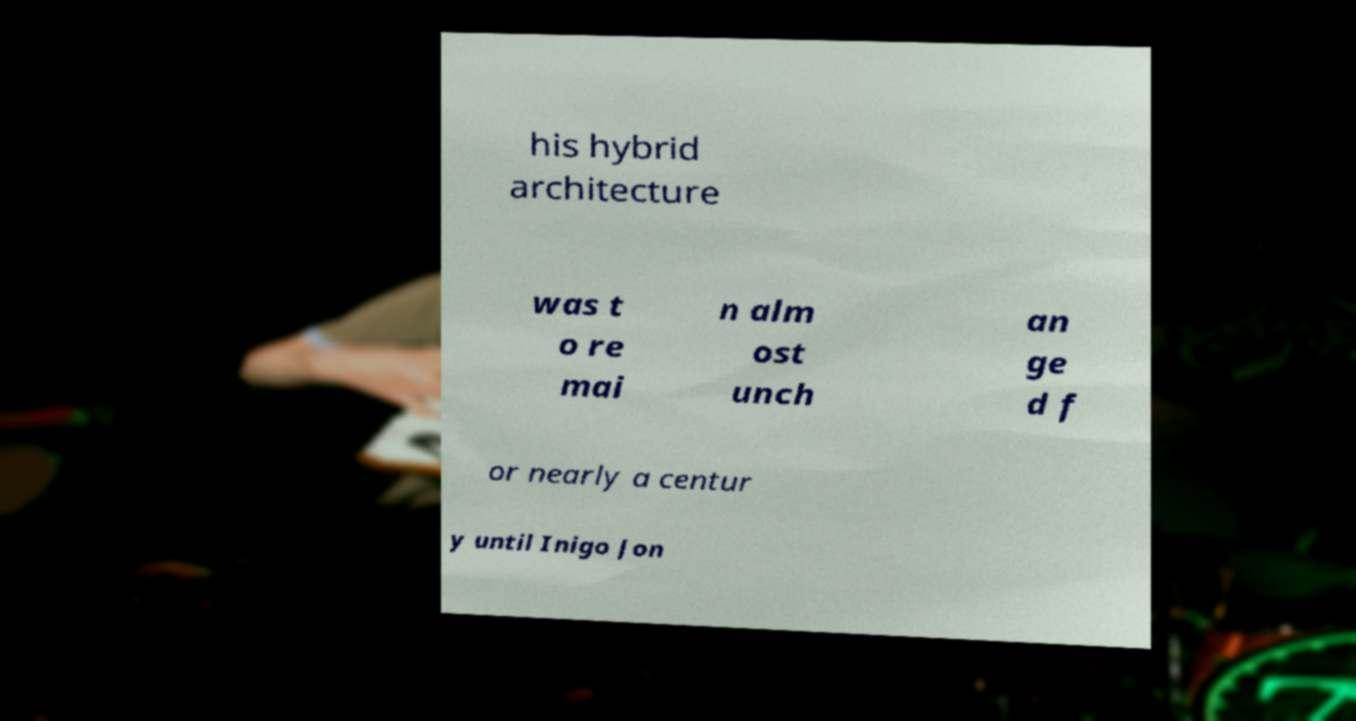Can you read and provide the text displayed in the image?This photo seems to have some interesting text. Can you extract and type it out for me? his hybrid architecture was t o re mai n alm ost unch an ge d f or nearly a centur y until Inigo Jon 